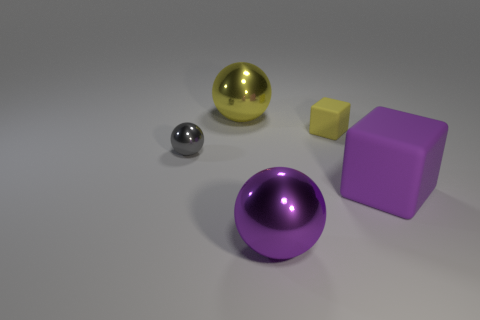Add 5 small balls. How many objects exist? 10 Subtract all spheres. How many objects are left? 2 Add 1 large yellow shiny spheres. How many large yellow shiny spheres are left? 2 Add 4 big purple matte objects. How many big purple matte objects exist? 5 Subtract 0 green balls. How many objects are left? 5 Subtract all yellow blocks. Subtract all purple balls. How many objects are left? 3 